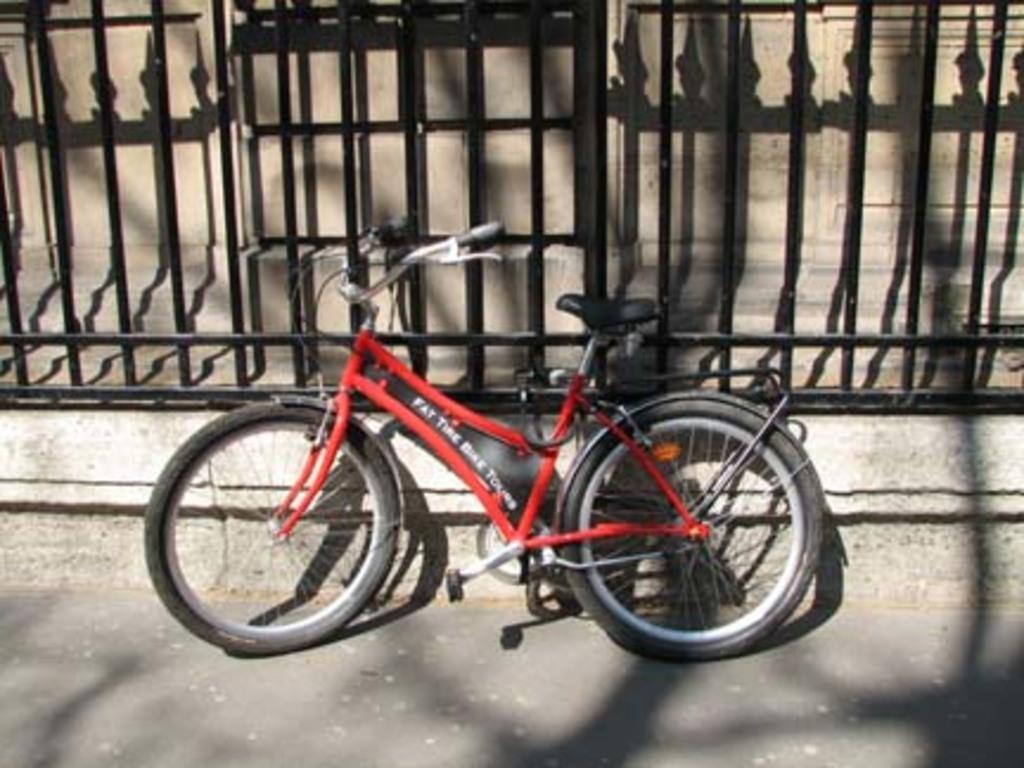How would you summarize this image in a sentence or two? In the foreground of the picture it is road. In the center of the picture there is a bicycle. At the top there are railing and wall. 